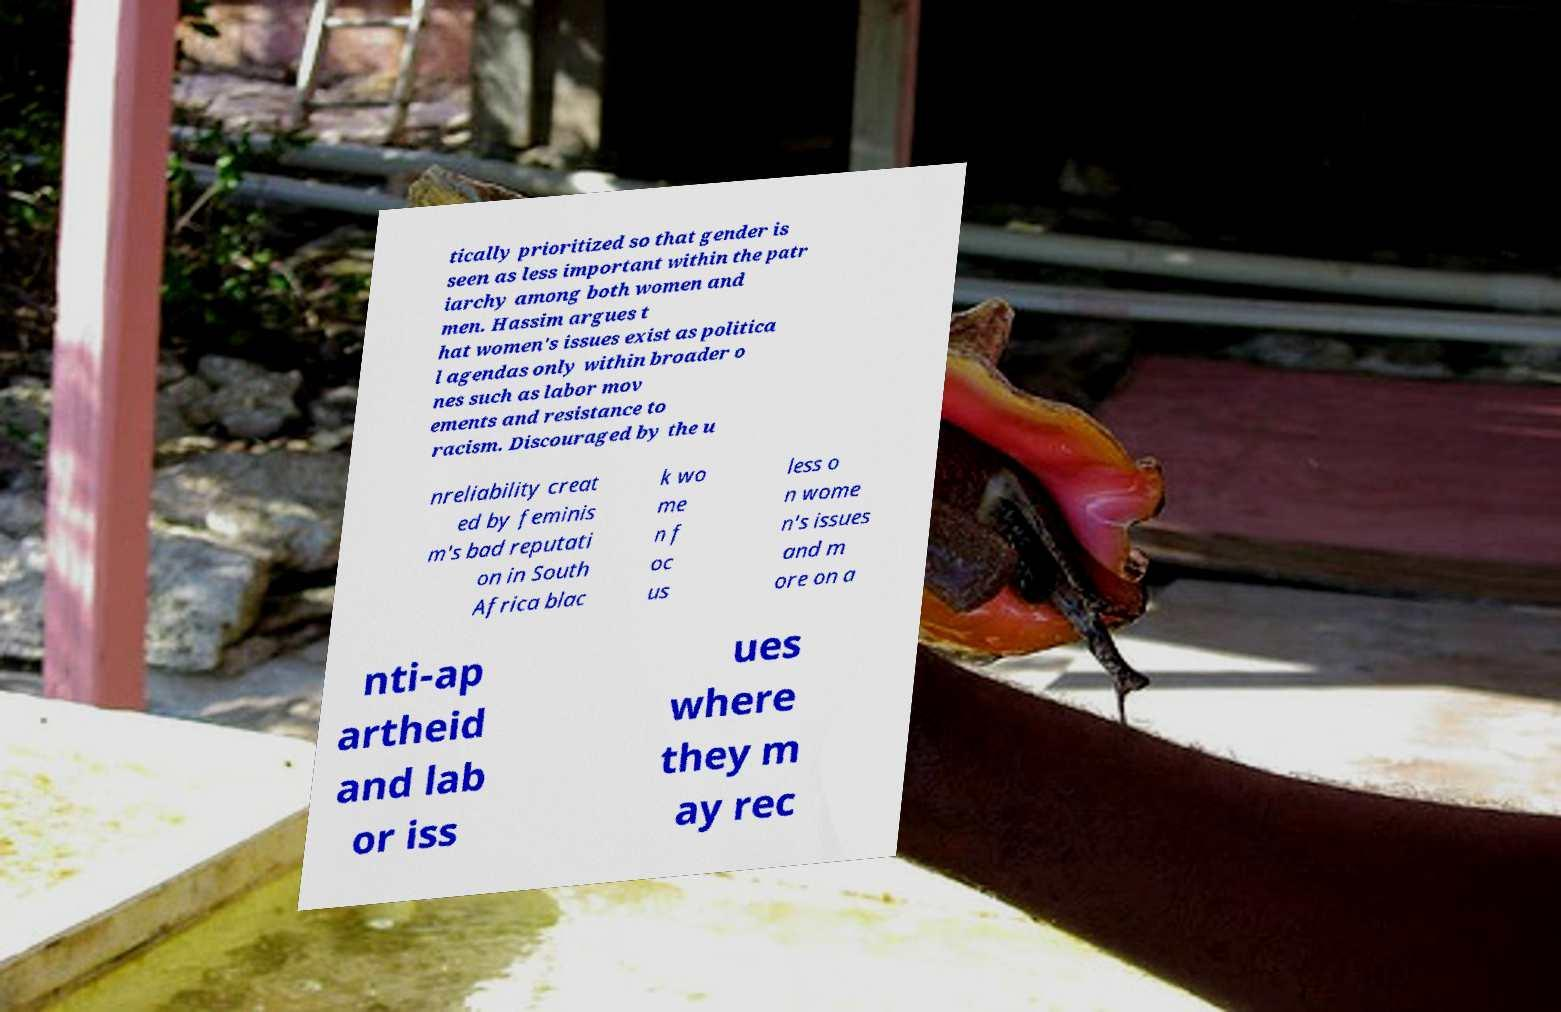Please read and relay the text visible in this image. What does it say? tically prioritized so that gender is seen as less important within the patr iarchy among both women and men. Hassim argues t hat women's issues exist as politica l agendas only within broader o nes such as labor mov ements and resistance to racism. Discouraged by the u nreliability creat ed by feminis m's bad reputati on in South Africa blac k wo me n f oc us less o n wome n's issues and m ore on a nti-ap artheid and lab or iss ues where they m ay rec 